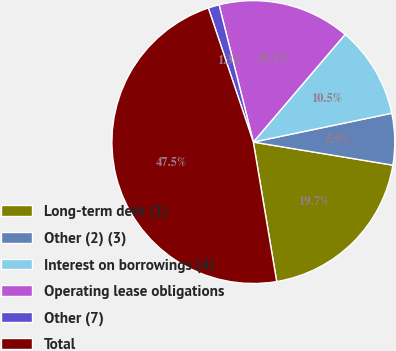Convert chart to OTSL. <chart><loc_0><loc_0><loc_500><loc_500><pie_chart><fcel>Long-term debt (1)<fcel>Other (2) (3)<fcel>Interest on borrowings (4)<fcel>Operating lease obligations<fcel>Other (7)<fcel>Total<nl><fcel>19.75%<fcel>5.88%<fcel>10.5%<fcel>15.13%<fcel>1.26%<fcel>47.49%<nl></chart> 